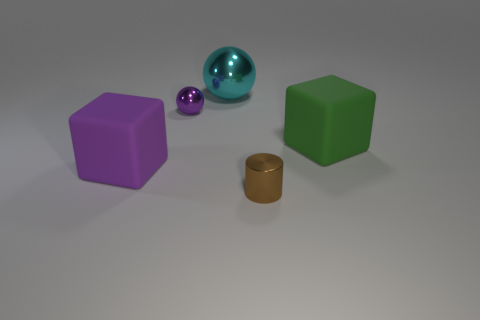The cyan metallic ball is what size?
Provide a short and direct response. Large. There is a big object that is right of the big purple cube and to the left of the cylinder; what is its shape?
Your answer should be very brief. Sphere. What color is the other big thing that is the same shape as the large purple object?
Your answer should be very brief. Green. How many objects are either tiny metallic things left of the big metallic thing or tiny metallic objects that are behind the green matte thing?
Make the answer very short. 1. What shape is the large green matte object?
Your answer should be compact. Cube. There is a rubber object that is the same color as the small ball; what is its shape?
Keep it short and to the point. Cube. How many cylinders are the same material as the brown thing?
Your response must be concise. 0. What color is the tiny cylinder?
Provide a short and direct response. Brown. What color is the other rubber block that is the same size as the green cube?
Keep it short and to the point. Purple. Is there a large matte block of the same color as the tiny sphere?
Offer a terse response. Yes. 